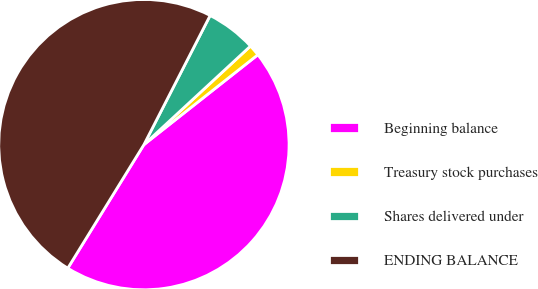Convert chart to OTSL. <chart><loc_0><loc_0><loc_500><loc_500><pie_chart><fcel>Beginning balance<fcel>Treasury stock purchases<fcel>Shares delivered under<fcel>ENDING BALANCE<nl><fcel>44.42%<fcel>1.25%<fcel>5.58%<fcel>48.75%<nl></chart> 